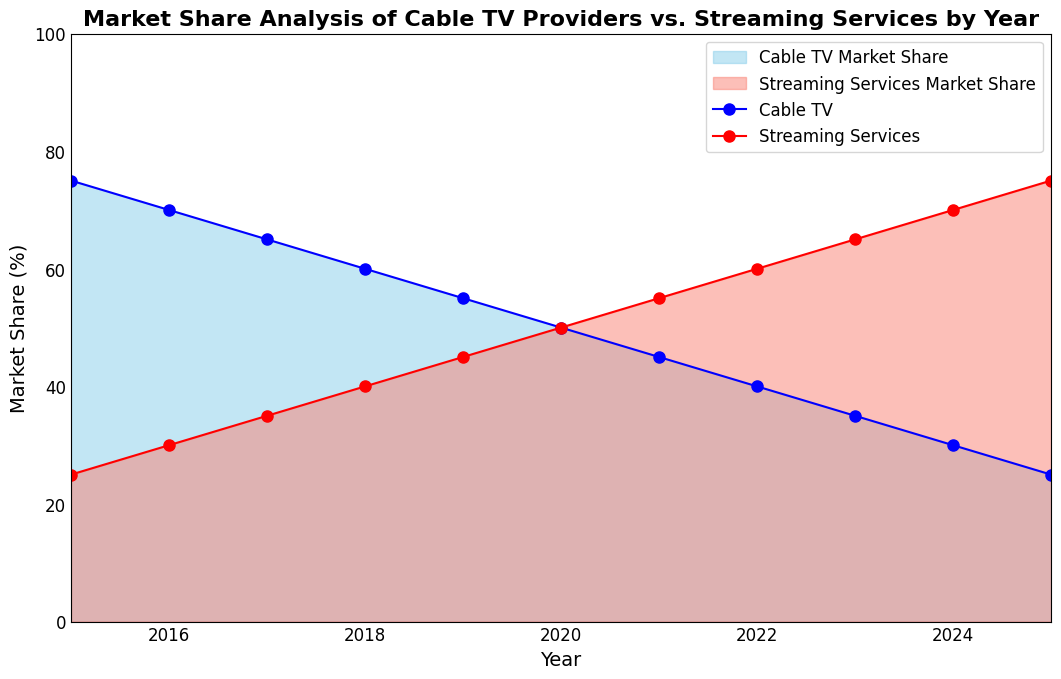What's the market share percentage of Cable TV in 2017? The chart shows that in the year 2017, the blue area representing Cable TV covers up to the 65% mark on the y-axis. Therefore, the market share percentage of Cable TV in 2017 is 65%
Answer: 65% In which year do Streaming Services and Cable TV have the same market share? By examining the plot, we can see that in the year 2020, both the blue and salmon areas intersect at the 50% mark, indicating that both Cable TV and Streaming Services had an equal market share.
Answer: 2020 What's the difference in the market share of Streaming Services between 2019 and 2023? In 2019, the market share for Streaming Services is 45% and in 2023 it is 65%. The difference is found by subtracting 45% from 65%, which is 20%.
Answer: 20% How has the market share trend changed for Cable TV from 2015 to 2025? From 2015 to 2025, the market share for Cable TV has steadily decreased. This can be seen by following the blue line in the plot, which declines consistently from 75% in 2015 to 25% in 2025.
Answer: Decreasing In what year did Streaming Services first surpass 50% market share, and by how much? The first year Streaming Services surpassed 50% market share is 2021. Looking at the plot, the red line reaches 55% in 2021, so Streaming Services exceeded 50% by 5%.
Answer: 2021, 5% Which year had the largest yearly decline in market share for Cable TV? Observing the plot, the largest yearly decline in the blue line representing Cable TV is between 2023 and 2024 where it drops from 35% to 30%, a decrease of 5%.
Answer: 2023-2024 How much is the total market share accounted for by both Cable TV and Streaming Services in the year 2022? In 2022, the market share for Cable TV is 40% and for Streaming Services is 60%. Adding these two percentages together gives 100%, which is expected since they represent the entire market.
Answer: 100% How does the slope of the Cable TV market share line compare to the slope of the Streaming Services market share line between 2015 and 2020? The slope of the Cable TV market share line is consistently negative and decreases at a steady rate, while the slope of the Streaming Services market share line is consistently positive and increasing at a steady rate. This is due to the reciprocal relationship as one increases and the other decreases.
Answer: Negative vs. Positive What was the market share for Streaming Services in 2016, and what’s the logical operation to interpret it from the chart? In 2016, following the salmon area on the plot, the Streaming Services market share is shown at 30%. The logical operation to interpret this involves identifying the corresponding y-axis value directly above the year 2016.
Answer: 30% 